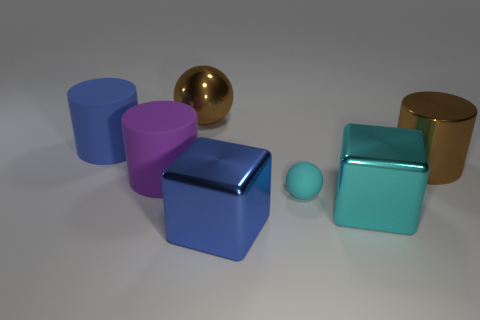What shape is the big metal object that is in front of the cyan cube?
Give a very brief answer. Cube. What is the material of the large thing that is the same color as the small thing?
Provide a short and direct response. Metal. The large rubber cylinder in front of the large brown thing to the right of the cyan rubber thing is what color?
Your response must be concise. Purple. Is the brown cylinder the same size as the blue rubber cylinder?
Keep it short and to the point. Yes. What material is the big blue object that is the same shape as the large purple matte object?
Provide a succinct answer. Rubber. How many other spheres are the same size as the brown metallic ball?
Offer a terse response. 0. The large object that is the same material as the big purple cylinder is what color?
Your response must be concise. Blue. Are there fewer cyan things than blue shiny cylinders?
Ensure brevity in your answer.  No. What number of green things are large spheres or rubber balls?
Your answer should be very brief. 0. How many large objects are both behind the big purple rubber thing and in front of the big metal ball?
Offer a terse response. 2. 